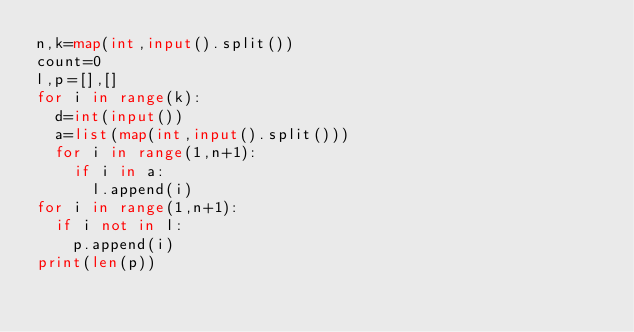<code> <loc_0><loc_0><loc_500><loc_500><_Python_>n,k=map(int,input().split())
count=0
l,p=[],[]
for i in range(k):
	d=int(input())
	a=list(map(int,input().split()))
	for i in range(1,n+1):
		if i in a:
			l.append(i)
for i in range(1,n+1):
	if i not in l:
		p.append(i)
print(len(p))
</code> 